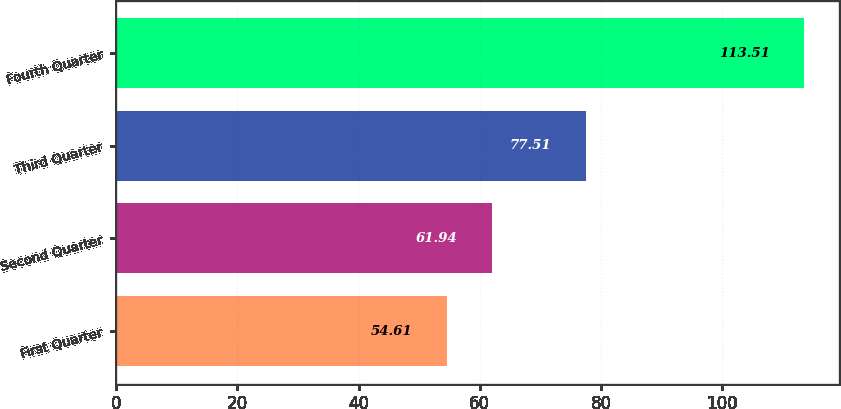Convert chart. <chart><loc_0><loc_0><loc_500><loc_500><bar_chart><fcel>First Quarter<fcel>Second Quarter<fcel>Third Quarter<fcel>Fourth Quarter<nl><fcel>54.61<fcel>61.94<fcel>77.51<fcel>113.51<nl></chart> 